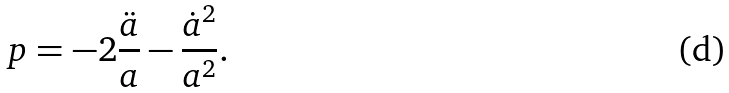Convert formula to latex. <formula><loc_0><loc_0><loc_500><loc_500>p = - 2 \frac { \ddot { a } } { a } - \frac { \dot { a } ^ { 2 } } { a ^ { 2 } } .</formula> 